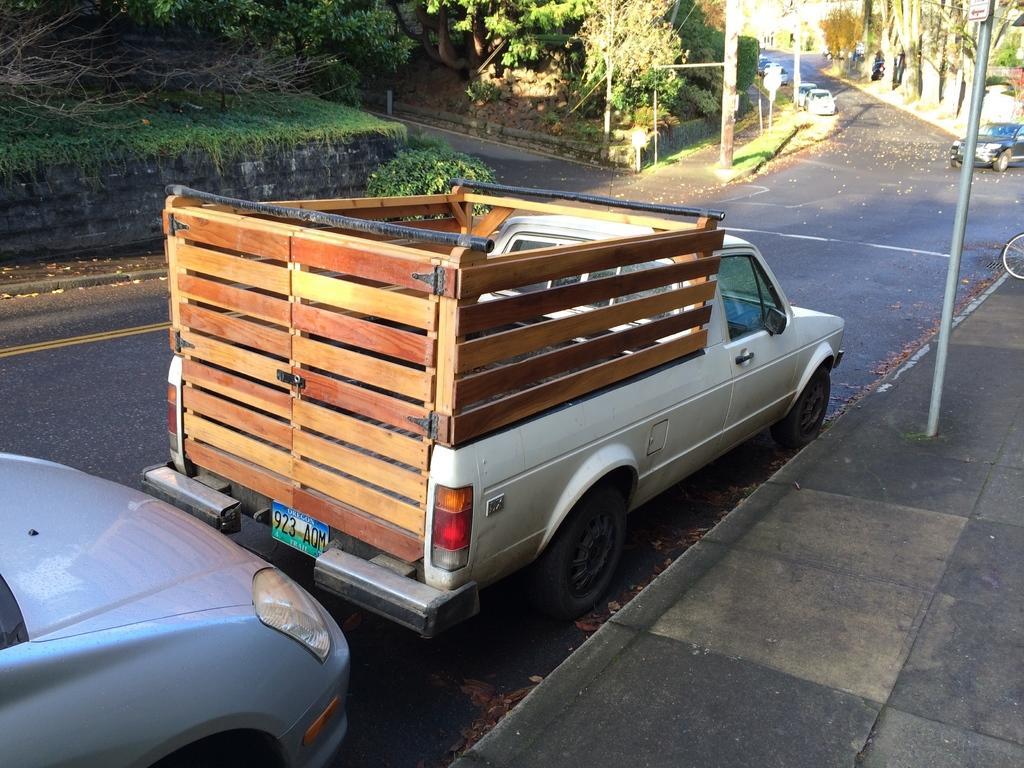Describe this image in one or two sentences. In this image, I can see a truck and the cars on the road. This looks like a pole. I can see the trees and bushes. This looks like the grass on the wall. On the right corner of the image, I can see a wheel. 